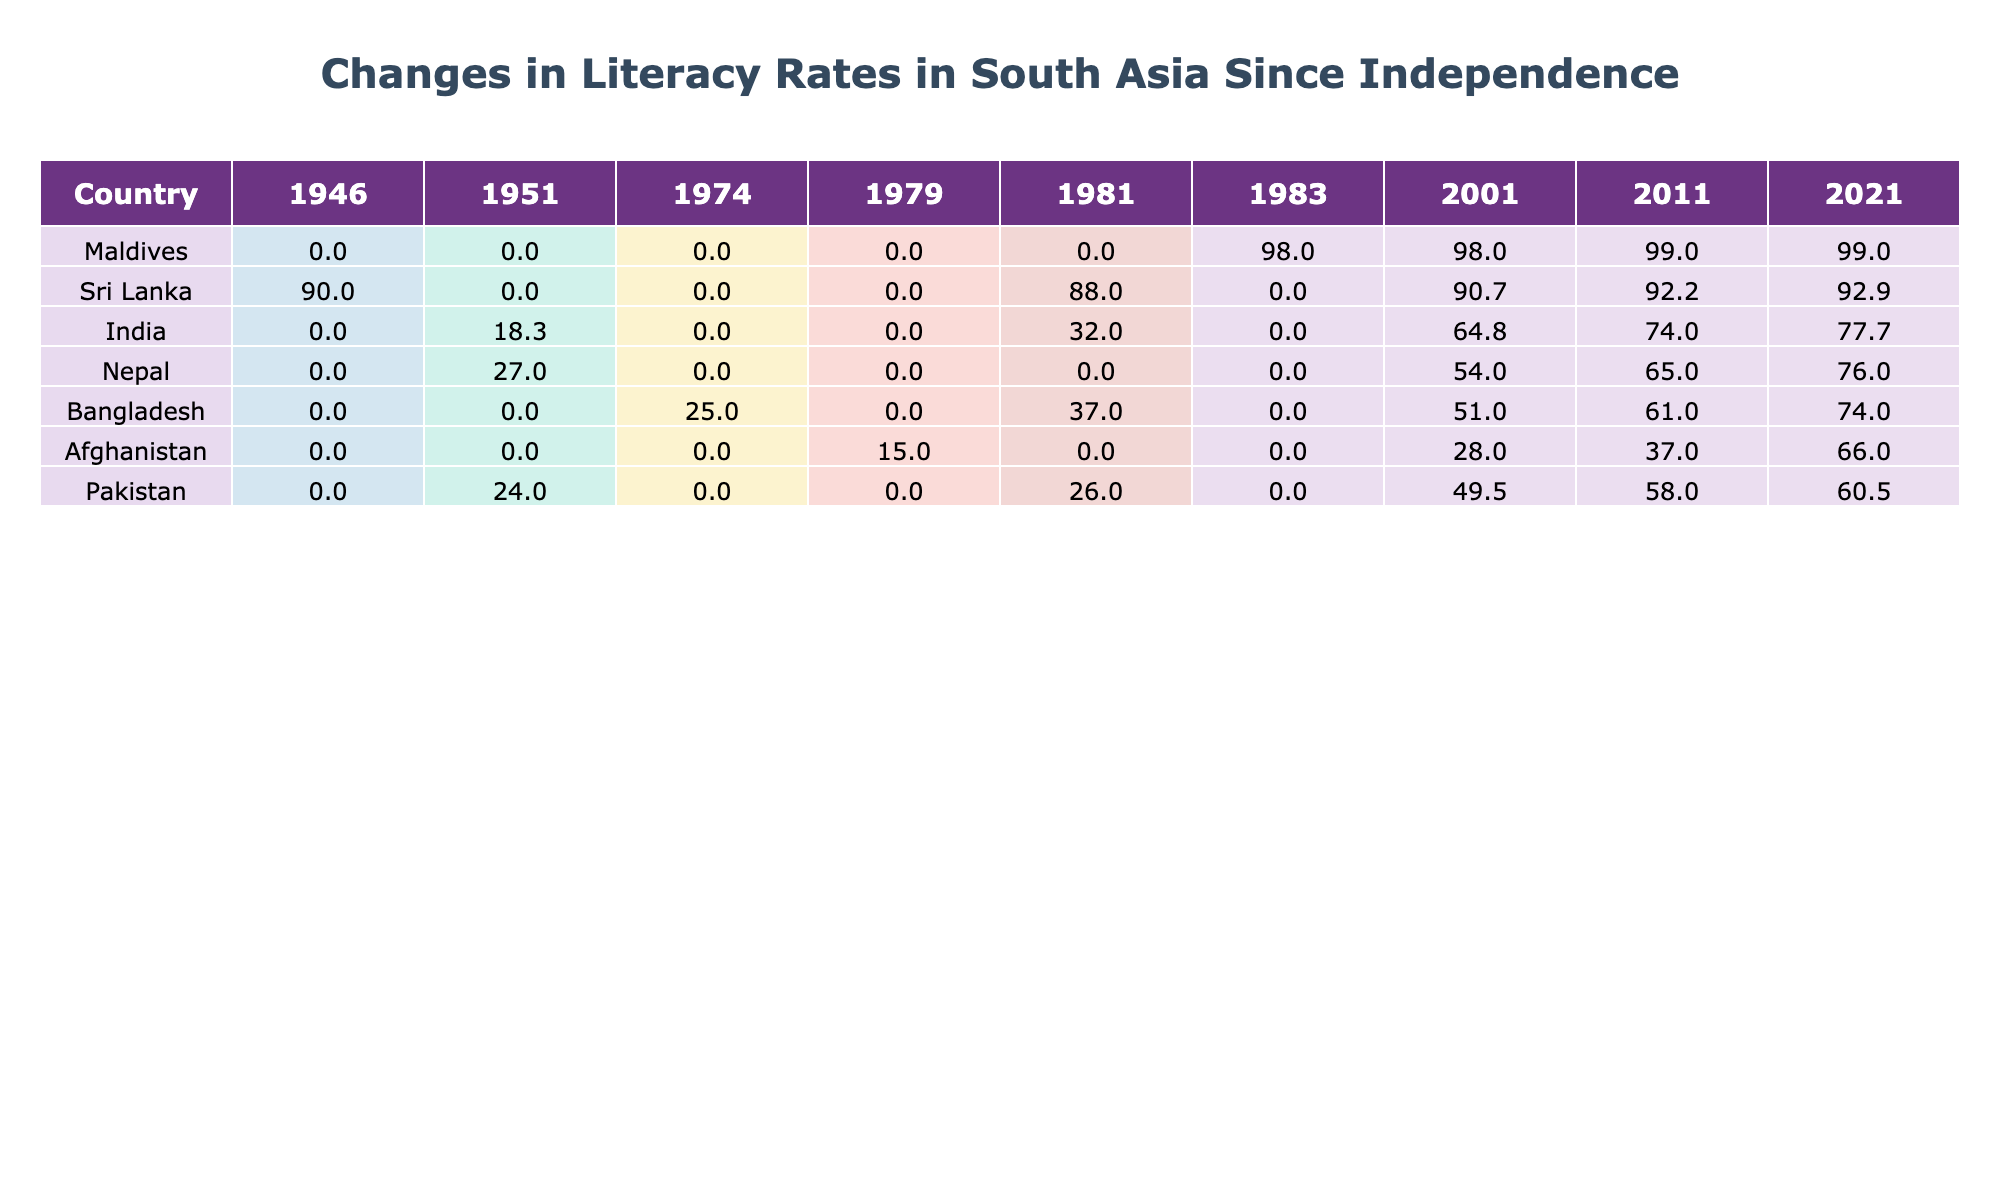What was the literacy rate in India in 2001? The table lists the literacy rates by year for India, showing that the value for 2001 is 64.8%.
Answer: 64.8% Which country had the highest literacy rate in 2021? By checking the last column for 2021, Sri Lanka is noted to have the highest literacy rate with 92.9%.
Answer: 92.9% What is the difference in literacy rates between Bangladesh and Nepal in 2011? For Bangladesh in 2011 the literacy rate is 61.0%, while in Nepal it is 65.0%. The difference is calculated as 65.0 - 61.0 = 4.0.
Answer: 4.0 Did Afghanistan's literacy rate increase between 2001 and 2021? The table shows that Afghanistan's literacy rates were 28.0% in 2001 and 66.0% in 2021. Since 66.0% is greater than 28.0%, this indicates an increase.
Answer: Yes What was the average literacy rate for Pakistan from 1951 to 2021? Summing the literacy rates for Pakistan (24.0, 26.0, 49.5, 58.0, 60.5) gives 218.0. Dividing by the number of years (5), the average is 218.0 / 5 = 43.6%.
Answer: 43.6% What year had the lowest recorded literacy rate for Bangladesh? The table reveals that Bangladesh's literacy rate was 25.0% in 1974, the lowest reading compared to all other years shown.
Answer: 1974 Which country showed the most improvement in literacy rates from 1951 to 2021? When analyzing the data, India started at 18.33% in 1951 and rose to 77.7% in 2021, a change of 59.37%. Comparing other countries similarly, it becomes evident that India shows the highest improvement.
Answer: India How does the literacy rate of the Maldives compare to Sri Lanka in 2021? In 2021, the Maldives literacy rate was 99.0% while Sri Lanka's was 92.9%. Since 99.0% is greater than 92.9%, the Maldives has a higher literacy rate.
Answer: Maldives has a higher rate 